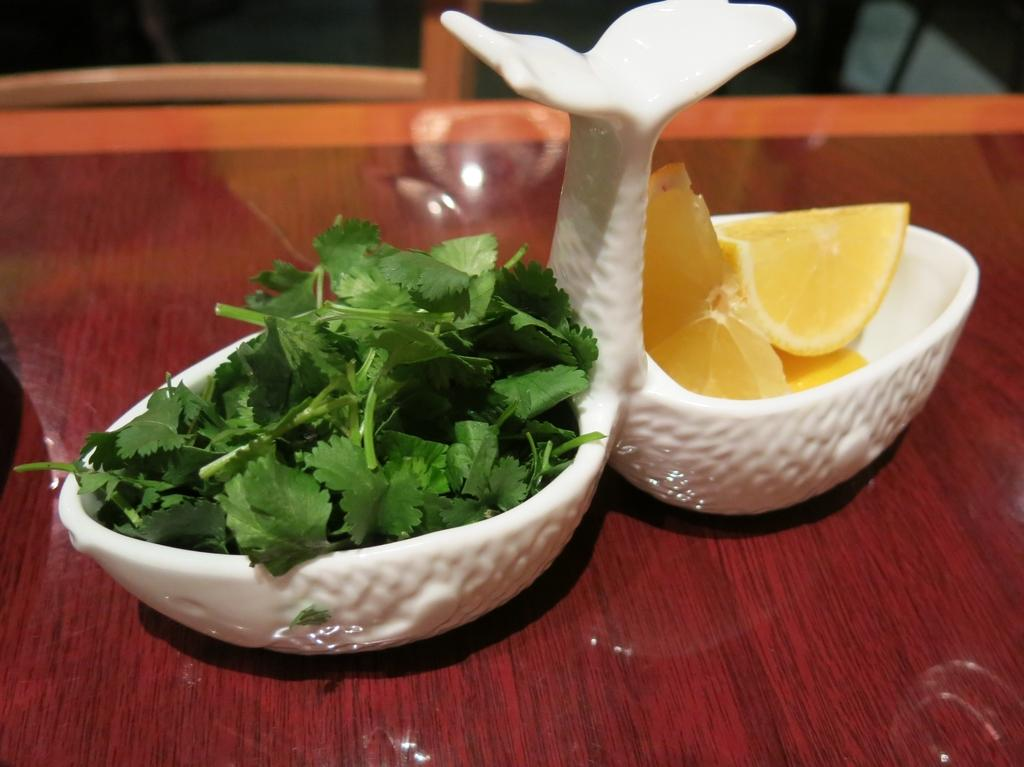What is located in the center of the image? There are baskets in the center of the image. What items can be found inside the baskets? The baskets contain lemons and coriander. What is at the bottom of the image? There is a table at the bottom of the image. Can you describe the background of the image? There are objects visible in the background of the image. Is there a cobweb visible on the table in the image? There is no mention of a cobweb in the provided facts, so we cannot determine if one is present in the image. What type of school is depicted in the image? There is no school present in the image; it features baskets, lemons, coriander, and a table. 